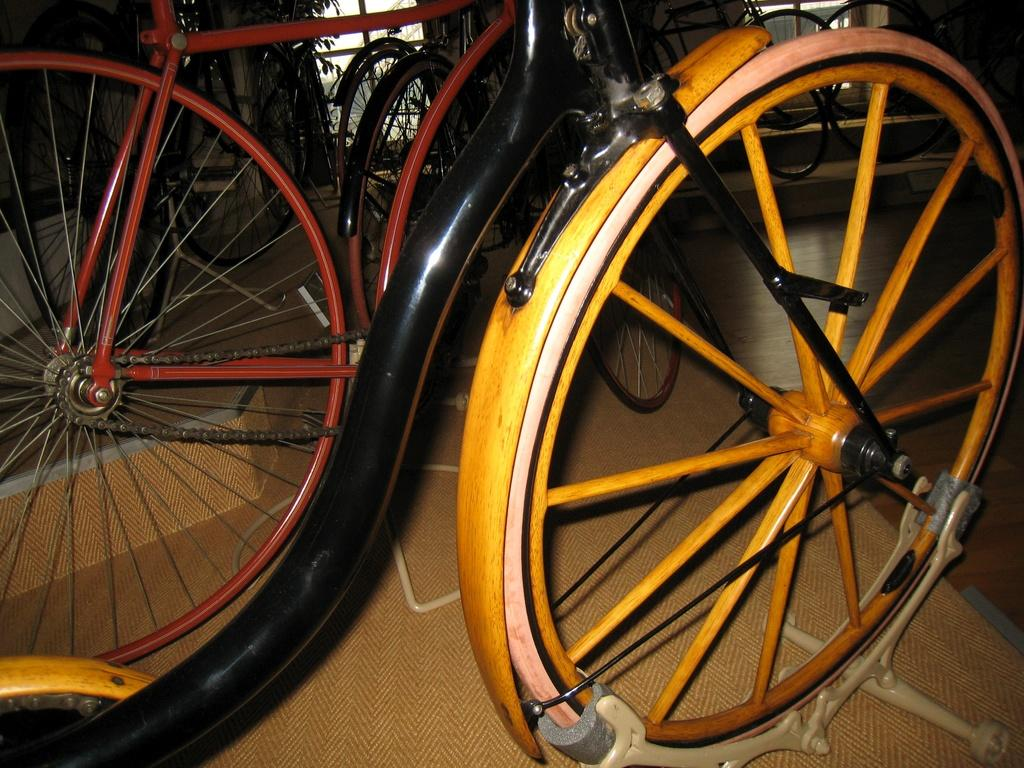What type of vehicles are in the image? There are bicycles in the image. What colors can be seen on the bicycles? The bicycles are in red, yellow, and black colors. What can be seen in the background of the image? There are trees and buildings in the background of the image. Where might this image have been taken? The image might have been taken in a bicycle garage. What type of ball is being used to wash the bicycles in the image? There is no ball or washing activity present in the image; it features bicycles in different colors with a background of trees and buildings. 